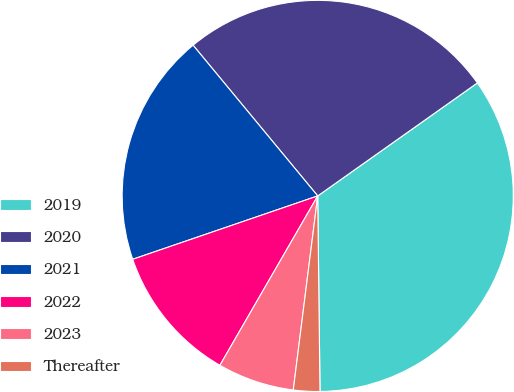Convert chart to OTSL. <chart><loc_0><loc_0><loc_500><loc_500><pie_chart><fcel>2019<fcel>2020<fcel>2021<fcel>2022<fcel>2023<fcel>Thereafter<nl><fcel>34.61%<fcel>26.19%<fcel>19.25%<fcel>11.41%<fcel>6.34%<fcel>2.18%<nl></chart> 